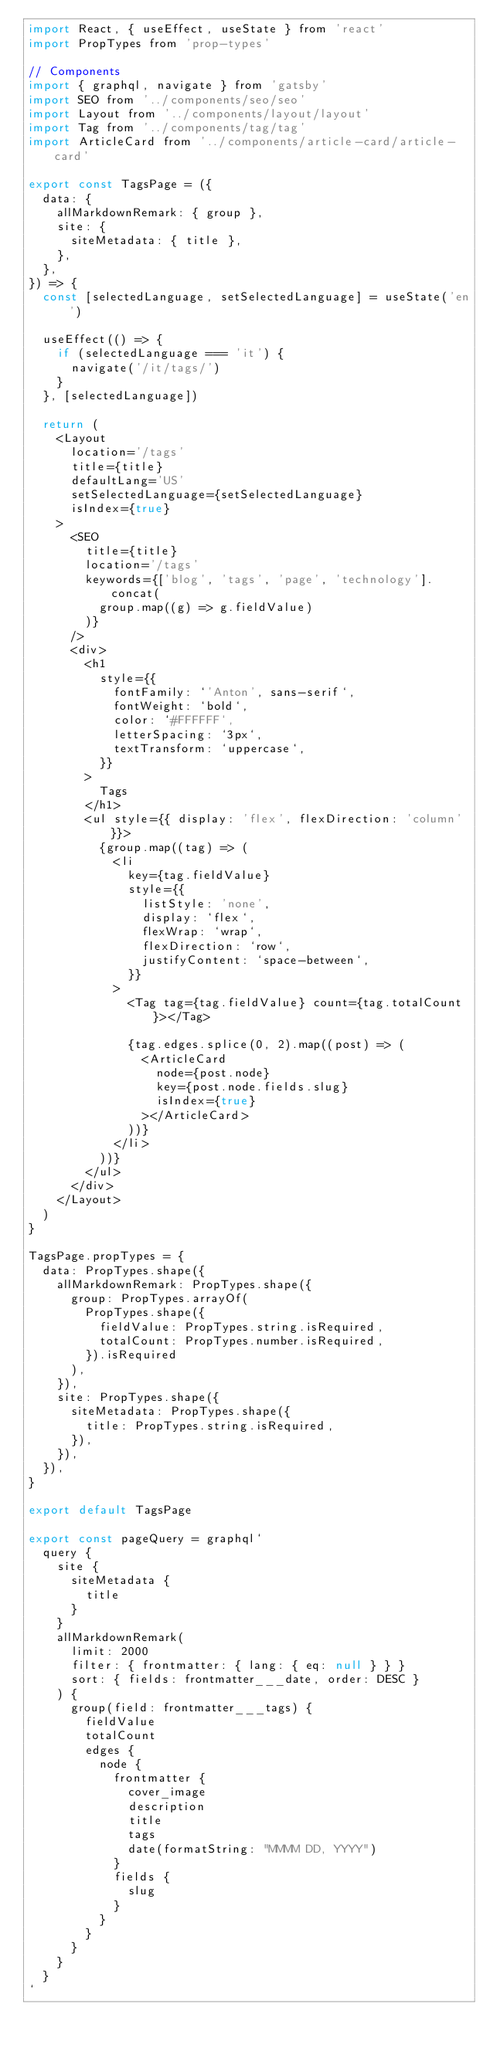Convert code to text. <code><loc_0><loc_0><loc_500><loc_500><_JavaScript_>import React, { useEffect, useState } from 'react'
import PropTypes from 'prop-types'

// Components
import { graphql, navigate } from 'gatsby'
import SEO from '../components/seo/seo'
import Layout from '../components/layout/layout'
import Tag from '../components/tag/tag'
import ArticleCard from '../components/article-card/article-card'

export const TagsPage = ({
  data: {
    allMarkdownRemark: { group },
    site: {
      siteMetadata: { title },
    },
  },
}) => {
  const [selectedLanguage, setSelectedLanguage] = useState('en')

  useEffect(() => {
    if (selectedLanguage === 'it') {
      navigate('/it/tags/')
    }
  }, [selectedLanguage])

  return (
    <Layout
      location='/tags'
      title={title}
      defaultLang='US'
      setSelectedLanguage={setSelectedLanguage}
      isIndex={true}
    >
      <SEO
        title={title}
        location='/tags'
        keywords={['blog', 'tags', 'page', 'technology'].concat(
          group.map((g) => g.fieldValue)
        )}
      />
      <div>
        <h1
          style={{
            fontFamily: `'Anton', sans-serif`,
            fontWeight: `bold`,
            color: `#FFFFFF`,
            letterSpacing: `3px`,
            textTransform: `uppercase`,
          }}
        >
          Tags
        </h1>
        <ul style={{ display: 'flex', flexDirection: 'column' }}>
          {group.map((tag) => (
            <li
              key={tag.fieldValue}
              style={{
                listStyle: 'none',
                display: `flex`,
                flexWrap: `wrap`,
                flexDirection: `row`,
                justifyContent: `space-between`,
              }}
            >
              <Tag tag={tag.fieldValue} count={tag.totalCount}></Tag>

              {tag.edges.splice(0, 2).map((post) => (
                <ArticleCard
                  node={post.node}
                  key={post.node.fields.slug}
                  isIndex={true}
                ></ArticleCard>
              ))}
            </li>
          ))}
        </ul>
      </div>
    </Layout>
  )
}

TagsPage.propTypes = {
  data: PropTypes.shape({
    allMarkdownRemark: PropTypes.shape({
      group: PropTypes.arrayOf(
        PropTypes.shape({
          fieldValue: PropTypes.string.isRequired,
          totalCount: PropTypes.number.isRequired,
        }).isRequired
      ),
    }),
    site: PropTypes.shape({
      siteMetadata: PropTypes.shape({
        title: PropTypes.string.isRequired,
      }),
    }),
  }),
}

export default TagsPage

export const pageQuery = graphql`
  query {
    site {
      siteMetadata {
        title
      }
    }
    allMarkdownRemark(
      limit: 2000
      filter: { frontmatter: { lang: { eq: null } } }
      sort: { fields: frontmatter___date, order: DESC }
    ) {
      group(field: frontmatter___tags) {
        fieldValue
        totalCount
        edges {
          node {
            frontmatter {
              cover_image
              description
              title
              tags
              date(formatString: "MMMM DD, YYYY")
            }
            fields {
              slug
            }
          }
        }
      }
    }
  }
`
</code> 